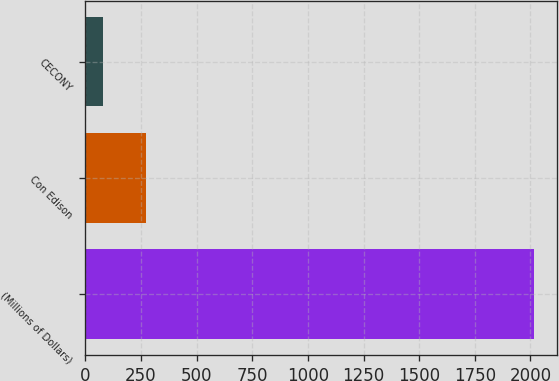<chart> <loc_0><loc_0><loc_500><loc_500><bar_chart><fcel>(Millions of Dollars)<fcel>Con Edison<fcel>CECONY<nl><fcel>2017<fcel>271<fcel>77<nl></chart> 